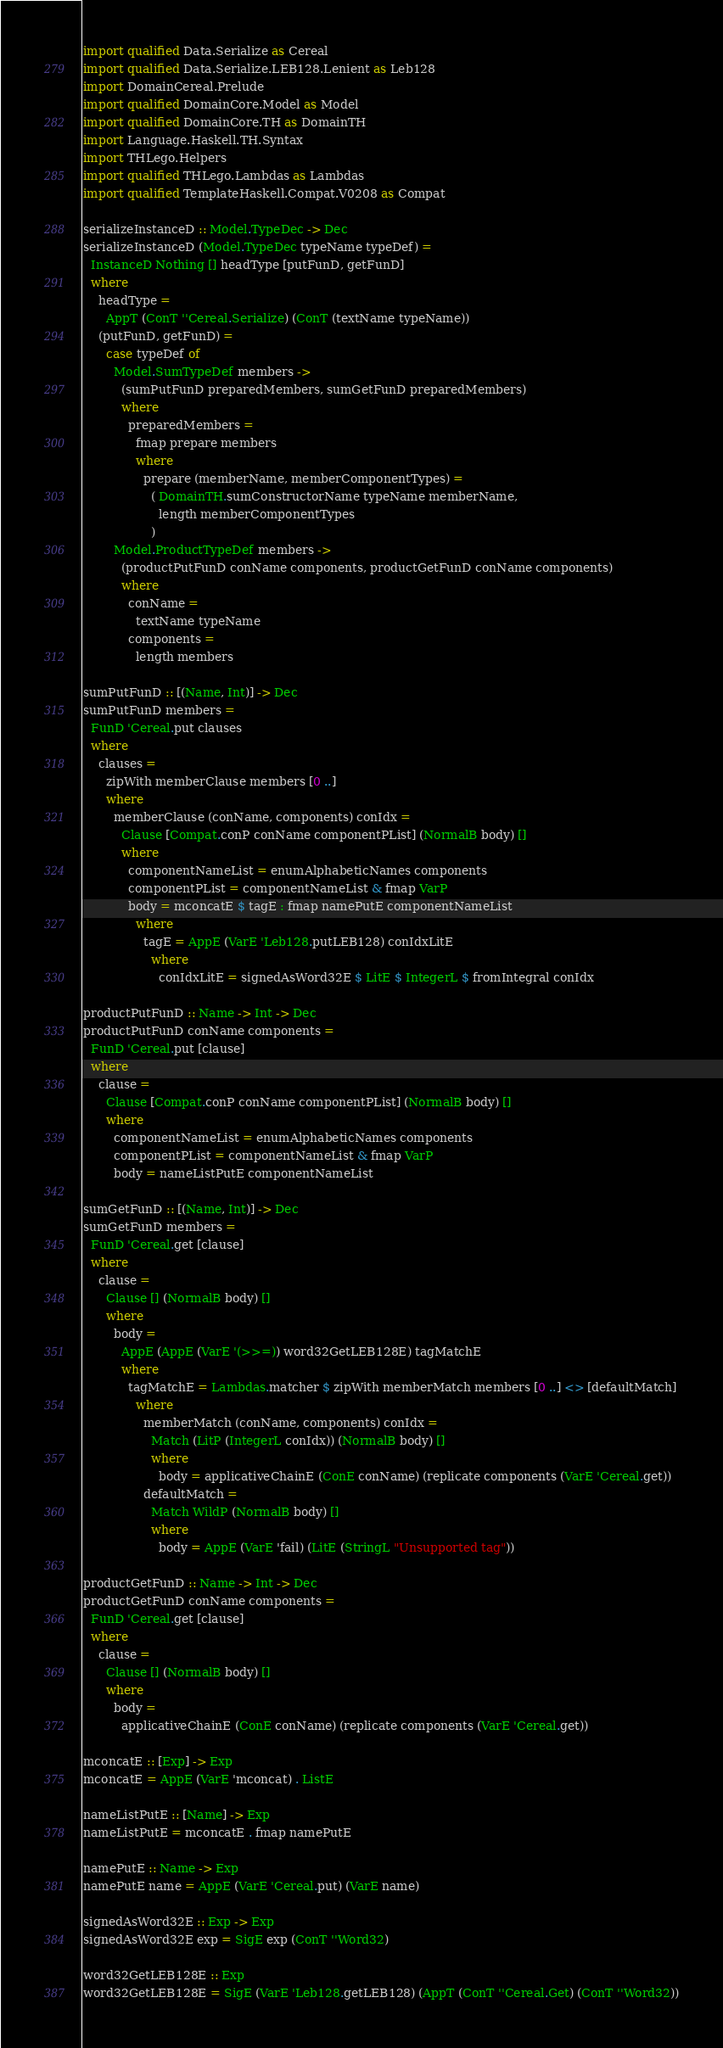Convert code to text. <code><loc_0><loc_0><loc_500><loc_500><_Haskell_>
import qualified Data.Serialize as Cereal
import qualified Data.Serialize.LEB128.Lenient as Leb128
import DomainCereal.Prelude
import qualified DomainCore.Model as Model
import qualified DomainCore.TH as DomainTH
import Language.Haskell.TH.Syntax
import THLego.Helpers
import qualified THLego.Lambdas as Lambdas
import qualified TemplateHaskell.Compat.V0208 as Compat

serializeInstanceD :: Model.TypeDec -> Dec
serializeInstanceD (Model.TypeDec typeName typeDef) =
  InstanceD Nothing [] headType [putFunD, getFunD]
  where
    headType =
      AppT (ConT ''Cereal.Serialize) (ConT (textName typeName))
    (putFunD, getFunD) =
      case typeDef of
        Model.SumTypeDef members ->
          (sumPutFunD preparedMembers, sumGetFunD preparedMembers)
          where
            preparedMembers =
              fmap prepare members
              where
                prepare (memberName, memberComponentTypes) =
                  ( DomainTH.sumConstructorName typeName memberName,
                    length memberComponentTypes
                  )
        Model.ProductTypeDef members ->
          (productPutFunD conName components, productGetFunD conName components)
          where
            conName =
              textName typeName
            components =
              length members

sumPutFunD :: [(Name, Int)] -> Dec
sumPutFunD members =
  FunD 'Cereal.put clauses
  where
    clauses =
      zipWith memberClause members [0 ..]
      where
        memberClause (conName, components) conIdx =
          Clause [Compat.conP conName componentPList] (NormalB body) []
          where
            componentNameList = enumAlphabeticNames components
            componentPList = componentNameList & fmap VarP
            body = mconcatE $ tagE : fmap namePutE componentNameList
              where
                tagE = AppE (VarE 'Leb128.putLEB128) conIdxLitE
                  where
                    conIdxLitE = signedAsWord32E $ LitE $ IntegerL $ fromIntegral conIdx

productPutFunD :: Name -> Int -> Dec
productPutFunD conName components =
  FunD 'Cereal.put [clause]
  where
    clause =
      Clause [Compat.conP conName componentPList] (NormalB body) []
      where
        componentNameList = enumAlphabeticNames components
        componentPList = componentNameList & fmap VarP
        body = nameListPutE componentNameList

sumGetFunD :: [(Name, Int)] -> Dec
sumGetFunD members =
  FunD 'Cereal.get [clause]
  where
    clause =
      Clause [] (NormalB body) []
      where
        body =
          AppE (AppE (VarE '(>>=)) word32GetLEB128E) tagMatchE
          where
            tagMatchE = Lambdas.matcher $ zipWith memberMatch members [0 ..] <> [defaultMatch]
              where
                memberMatch (conName, components) conIdx =
                  Match (LitP (IntegerL conIdx)) (NormalB body) []
                  where
                    body = applicativeChainE (ConE conName) (replicate components (VarE 'Cereal.get))
                defaultMatch =
                  Match WildP (NormalB body) []
                  where
                    body = AppE (VarE 'fail) (LitE (StringL "Unsupported tag"))

productGetFunD :: Name -> Int -> Dec
productGetFunD conName components =
  FunD 'Cereal.get [clause]
  where
    clause =
      Clause [] (NormalB body) []
      where
        body =
          applicativeChainE (ConE conName) (replicate components (VarE 'Cereal.get))

mconcatE :: [Exp] -> Exp
mconcatE = AppE (VarE 'mconcat) . ListE

nameListPutE :: [Name] -> Exp
nameListPutE = mconcatE . fmap namePutE

namePutE :: Name -> Exp
namePutE name = AppE (VarE 'Cereal.put) (VarE name)

signedAsWord32E :: Exp -> Exp
signedAsWord32E exp = SigE exp (ConT ''Word32)

word32GetLEB128E :: Exp
word32GetLEB128E = SigE (VarE 'Leb128.getLEB128) (AppT (ConT ''Cereal.Get) (ConT ''Word32))
</code> 